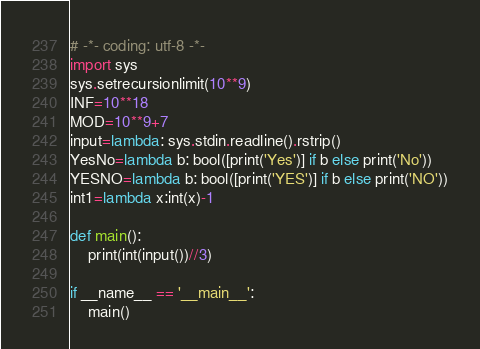Convert code to text. <code><loc_0><loc_0><loc_500><loc_500><_Python_># -*- coding: utf-8 -*-
import sys
sys.setrecursionlimit(10**9)
INF=10**18
MOD=10**9+7
input=lambda: sys.stdin.readline().rstrip()
YesNo=lambda b: bool([print('Yes')] if b else print('No'))
YESNO=lambda b: bool([print('YES')] if b else print('NO'))
int1=lambda x:int(x)-1

def main():
    print(int(input())//3)

if __name__ == '__main__':
    main()
</code> 